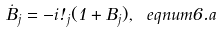<formula> <loc_0><loc_0><loc_500><loc_500>\dot { B } _ { j } = - i \omega _ { j } ( 1 + B _ { j } ) , \ e q n u m { 6 . a }</formula> 